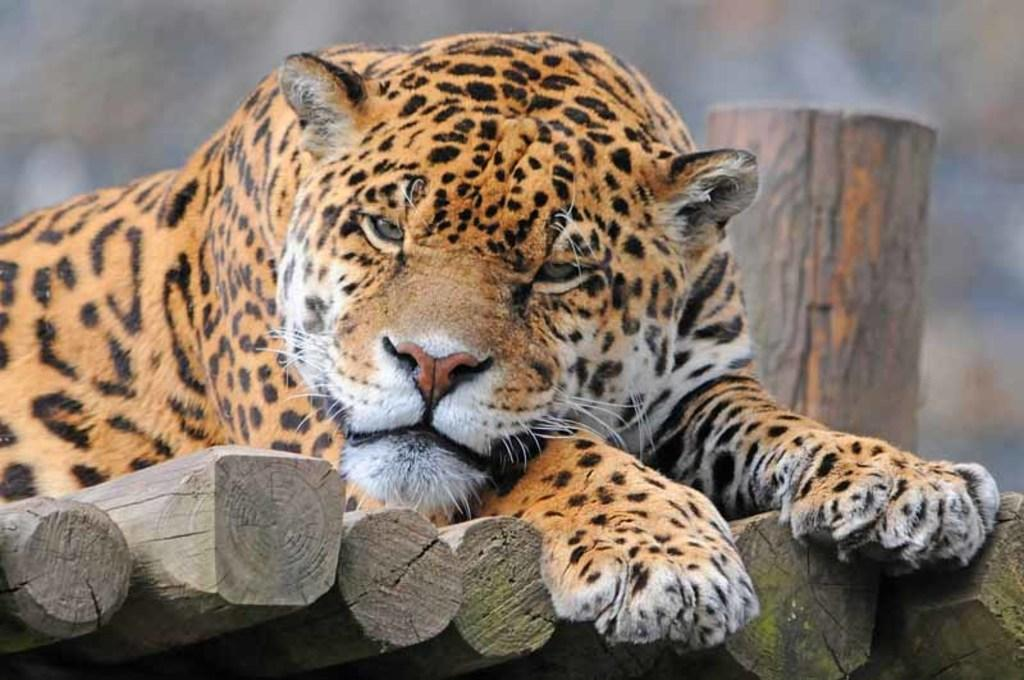What animal is the main subject of the image? There is a tiger in the image. How is the tiger positioned in the image? The tiger is on wooden poles. Can you describe the background of the image? The background of the image is blurred. What hobbies does the tiger enjoy during the week in the image? There is no information about the tiger's hobbies or the week in the image, as it only shows the tiger on wooden poles with a blurred background. 